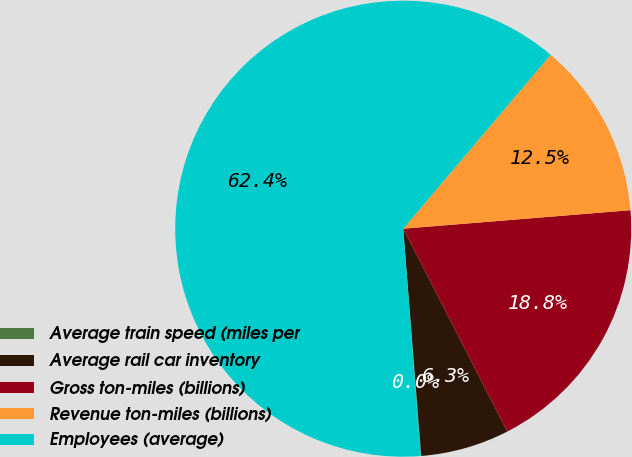<chart> <loc_0><loc_0><loc_500><loc_500><pie_chart><fcel>Average train speed (miles per<fcel>Average rail car inventory<fcel>Gross ton-miles (billions)<fcel>Revenue ton-miles (billions)<fcel>Employees (average)<nl><fcel>0.04%<fcel>6.28%<fcel>18.75%<fcel>12.51%<fcel>62.42%<nl></chart> 